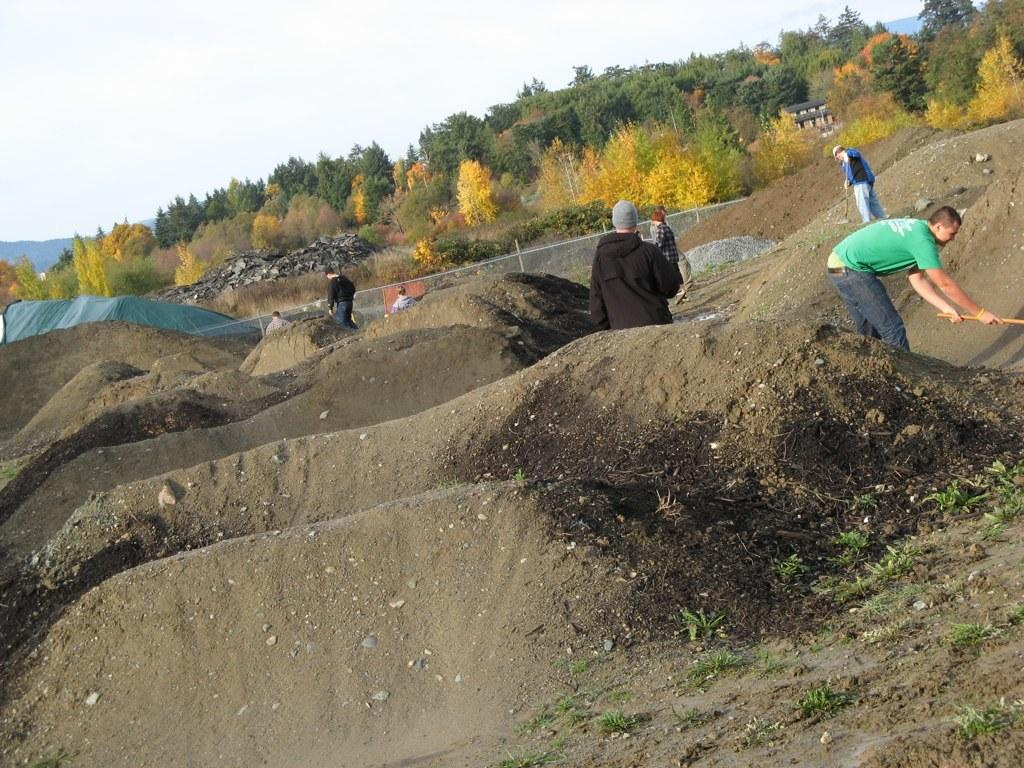How many people are in the image? There is a group of people standing in the image. What type of terrain is visible in the image? There is sand visible in the image. What type of vegetation is present in the image? There are trees in the image. What type of barrier is visible in the image? There is a fence in the image. What type of structure is visible in the image? There is a house in the image. What is visible in the background of the image? The sky is visible in the background of the image. What type of gun is being used by the trees in the image? There are no guns present in the image, and the trees are not using any objects. 